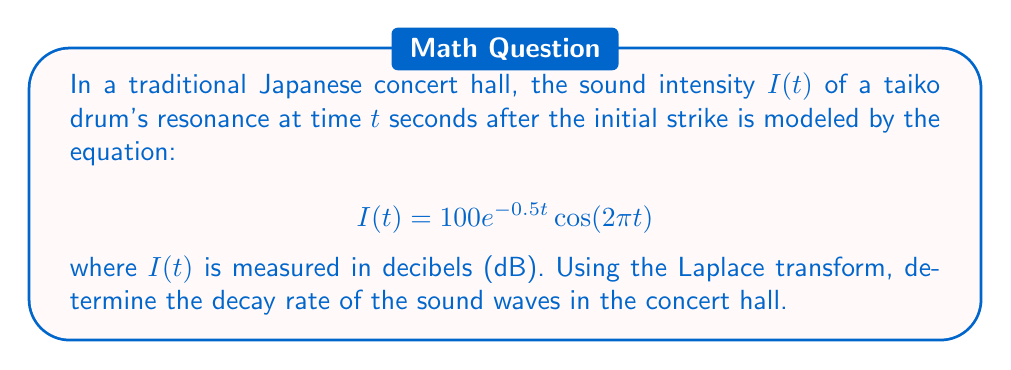Solve this math problem. To solve this problem, we'll follow these steps:

1) First, we need to take the Laplace transform of $I(t)$. Let's denote the Laplace transform of $I(t)$ as $\mathcal{L}\{I(t)\} = F(s)$.

2) The Laplace transform of $e^{at}\cos(bt)$ is given by:

   $$\mathcal{L}\{e^{at}\cos(bt)\} = \frac{s-a}{(s-a)^2 + b^2}$$

3) In our case, $a = -0.5$ and $b = 2\pi$. Also, we have a constant factor of 100. So:

   $$F(s) = 100 \cdot \frac{s+0.5}{(s+0.5)^2 + (2\pi)^2}$$

4) To find the decay rate, we need to look at the poles of this function. The poles are the values of $s$ that make the denominator zero:

   $$(s+0.5)^2 + (2\pi)^2 = 0$$

5) Solving this equation:

   $$s+0.5 = \pm 2\pi i$$
   $$s = -0.5 \pm 2\pi i$$

6) The real part of these poles (-0.5) represents the decay rate of the sound waves.

7) Therefore, the decay rate is 0.5 per second.

This means that the amplitude of the sound waves decreases by a factor of $e^{-0.5} \approx 0.607$ every second.
Answer: The decay rate of the sound waves in the traditional Japanese concert hall is 0.5 per second. 